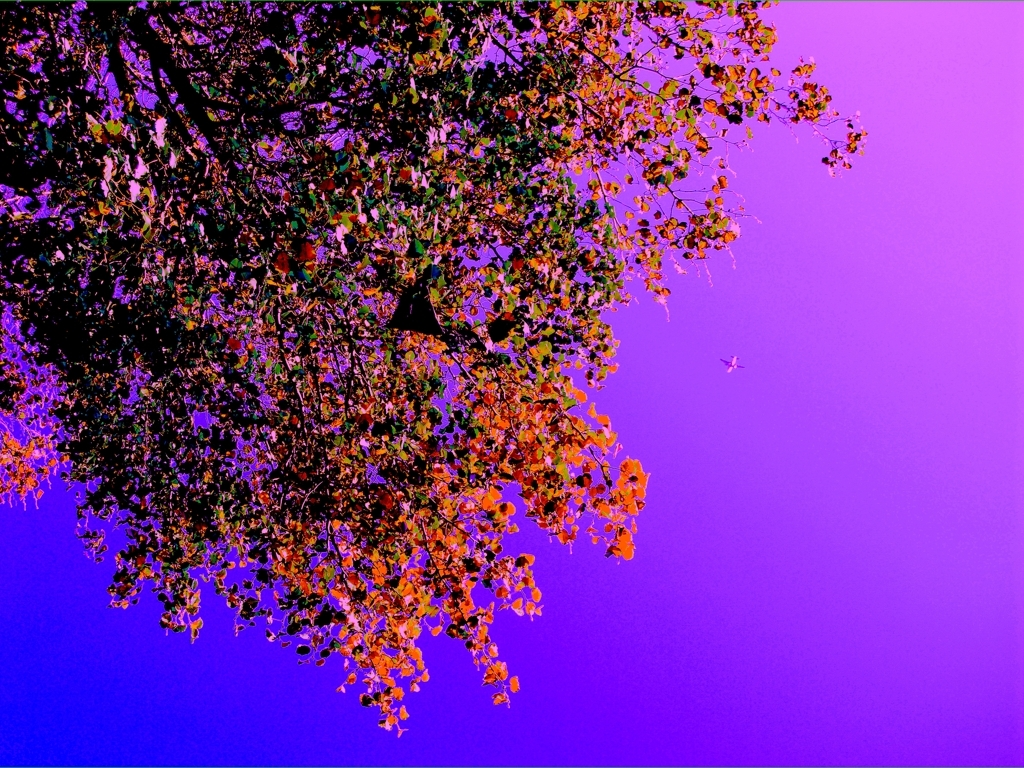What time of day do you think this photo was taken? Based on the lighting and the colors used, it's difficult to determine the actual time of day. The scene could be representing either dusk or dawn, given the purple hues, but these may also be the result of artistic color manipulation. 